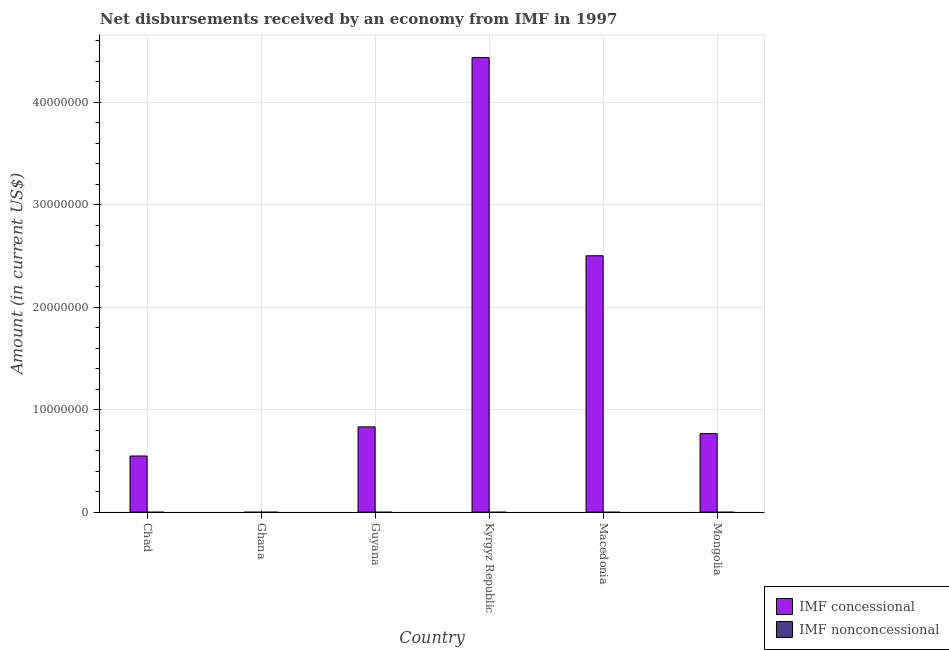Are the number of bars on each tick of the X-axis equal?
Keep it short and to the point. No. How many bars are there on the 6th tick from the left?
Your answer should be very brief. 1. What is the label of the 6th group of bars from the left?
Your response must be concise. Mongolia. In how many cases, is the number of bars for a given country not equal to the number of legend labels?
Offer a very short reply. 6. What is the net concessional disbursements from imf in Kyrgyz Republic?
Provide a short and direct response. 4.44e+07. Across all countries, what is the maximum net concessional disbursements from imf?
Your answer should be compact. 4.44e+07. Across all countries, what is the minimum net non concessional disbursements from imf?
Your answer should be compact. 0. In which country was the net concessional disbursements from imf maximum?
Make the answer very short. Kyrgyz Republic. What is the total net concessional disbursements from imf in the graph?
Offer a terse response. 9.09e+07. What is the difference between the net concessional disbursements from imf in Guyana and that in Kyrgyz Republic?
Make the answer very short. -3.61e+07. What is the difference between the net non concessional disbursements from imf in Chad and the net concessional disbursements from imf in Macedonia?
Make the answer very short. -2.50e+07. What is the average net concessional disbursements from imf per country?
Your response must be concise. 1.51e+07. In how many countries, is the net concessional disbursements from imf greater than 36000000 US$?
Give a very brief answer. 1. What is the ratio of the net concessional disbursements from imf in Chad to that in Macedonia?
Give a very brief answer. 0.22. Is the net concessional disbursements from imf in Guyana less than that in Mongolia?
Your answer should be compact. No. What is the difference between the highest and the second highest net concessional disbursements from imf?
Make the answer very short. 1.94e+07. What is the difference between the highest and the lowest net concessional disbursements from imf?
Your answer should be compact. 4.44e+07. Are all the bars in the graph horizontal?
Offer a very short reply. No. What is the difference between two consecutive major ticks on the Y-axis?
Offer a very short reply. 1.00e+07. What is the title of the graph?
Give a very brief answer. Net disbursements received by an economy from IMF in 1997. What is the label or title of the X-axis?
Keep it short and to the point. Country. What is the label or title of the Y-axis?
Provide a short and direct response. Amount (in current US$). What is the Amount (in current US$) of IMF concessional in Chad?
Your answer should be compact. 5.47e+06. What is the Amount (in current US$) of IMF concessional in Ghana?
Provide a succinct answer. 0. What is the Amount (in current US$) of IMF concessional in Guyana?
Provide a short and direct response. 8.32e+06. What is the Amount (in current US$) of IMF nonconcessional in Guyana?
Give a very brief answer. 0. What is the Amount (in current US$) of IMF concessional in Kyrgyz Republic?
Make the answer very short. 4.44e+07. What is the Amount (in current US$) in IMF nonconcessional in Kyrgyz Republic?
Make the answer very short. 0. What is the Amount (in current US$) of IMF concessional in Macedonia?
Ensure brevity in your answer.  2.50e+07. What is the Amount (in current US$) of IMF concessional in Mongolia?
Keep it short and to the point. 7.66e+06. Across all countries, what is the maximum Amount (in current US$) of IMF concessional?
Your answer should be compact. 4.44e+07. What is the total Amount (in current US$) of IMF concessional in the graph?
Offer a terse response. 9.09e+07. What is the total Amount (in current US$) in IMF nonconcessional in the graph?
Make the answer very short. 0. What is the difference between the Amount (in current US$) of IMF concessional in Chad and that in Guyana?
Your response must be concise. -2.84e+06. What is the difference between the Amount (in current US$) of IMF concessional in Chad and that in Kyrgyz Republic?
Give a very brief answer. -3.89e+07. What is the difference between the Amount (in current US$) in IMF concessional in Chad and that in Macedonia?
Provide a short and direct response. -1.96e+07. What is the difference between the Amount (in current US$) of IMF concessional in Chad and that in Mongolia?
Provide a short and direct response. -2.19e+06. What is the difference between the Amount (in current US$) of IMF concessional in Guyana and that in Kyrgyz Republic?
Provide a short and direct response. -3.61e+07. What is the difference between the Amount (in current US$) of IMF concessional in Guyana and that in Macedonia?
Ensure brevity in your answer.  -1.67e+07. What is the difference between the Amount (in current US$) in IMF concessional in Guyana and that in Mongolia?
Offer a very short reply. 6.58e+05. What is the difference between the Amount (in current US$) of IMF concessional in Kyrgyz Republic and that in Macedonia?
Your response must be concise. 1.94e+07. What is the difference between the Amount (in current US$) of IMF concessional in Kyrgyz Republic and that in Mongolia?
Provide a succinct answer. 3.67e+07. What is the difference between the Amount (in current US$) of IMF concessional in Macedonia and that in Mongolia?
Provide a short and direct response. 1.74e+07. What is the average Amount (in current US$) of IMF concessional per country?
Offer a terse response. 1.51e+07. What is the average Amount (in current US$) in IMF nonconcessional per country?
Provide a succinct answer. 0. What is the ratio of the Amount (in current US$) of IMF concessional in Chad to that in Guyana?
Provide a succinct answer. 0.66. What is the ratio of the Amount (in current US$) of IMF concessional in Chad to that in Kyrgyz Republic?
Give a very brief answer. 0.12. What is the ratio of the Amount (in current US$) in IMF concessional in Chad to that in Macedonia?
Provide a succinct answer. 0.22. What is the ratio of the Amount (in current US$) in IMF concessional in Chad to that in Mongolia?
Provide a short and direct response. 0.71. What is the ratio of the Amount (in current US$) in IMF concessional in Guyana to that in Kyrgyz Republic?
Make the answer very short. 0.19. What is the ratio of the Amount (in current US$) of IMF concessional in Guyana to that in Macedonia?
Your response must be concise. 0.33. What is the ratio of the Amount (in current US$) in IMF concessional in Guyana to that in Mongolia?
Provide a succinct answer. 1.09. What is the ratio of the Amount (in current US$) of IMF concessional in Kyrgyz Republic to that in Macedonia?
Provide a short and direct response. 1.77. What is the ratio of the Amount (in current US$) in IMF concessional in Kyrgyz Republic to that in Mongolia?
Your answer should be compact. 5.8. What is the ratio of the Amount (in current US$) of IMF concessional in Macedonia to that in Mongolia?
Provide a short and direct response. 3.27. What is the difference between the highest and the second highest Amount (in current US$) in IMF concessional?
Keep it short and to the point. 1.94e+07. What is the difference between the highest and the lowest Amount (in current US$) in IMF concessional?
Your response must be concise. 4.44e+07. 